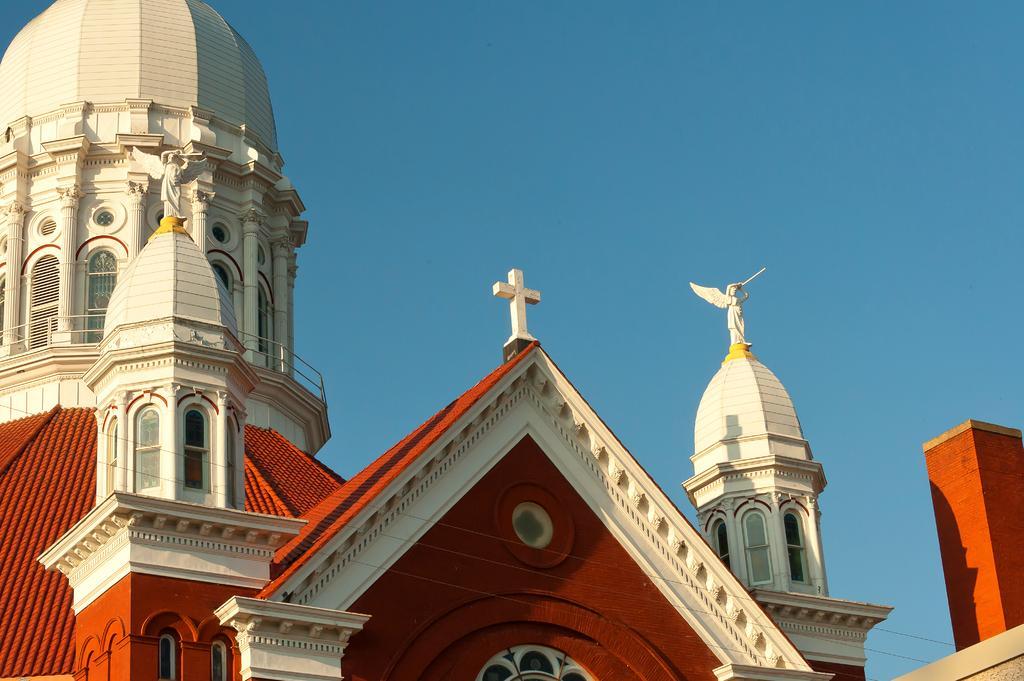Please provide a concise description of this image. In this image, we can see a building and at the top, there is sky. 